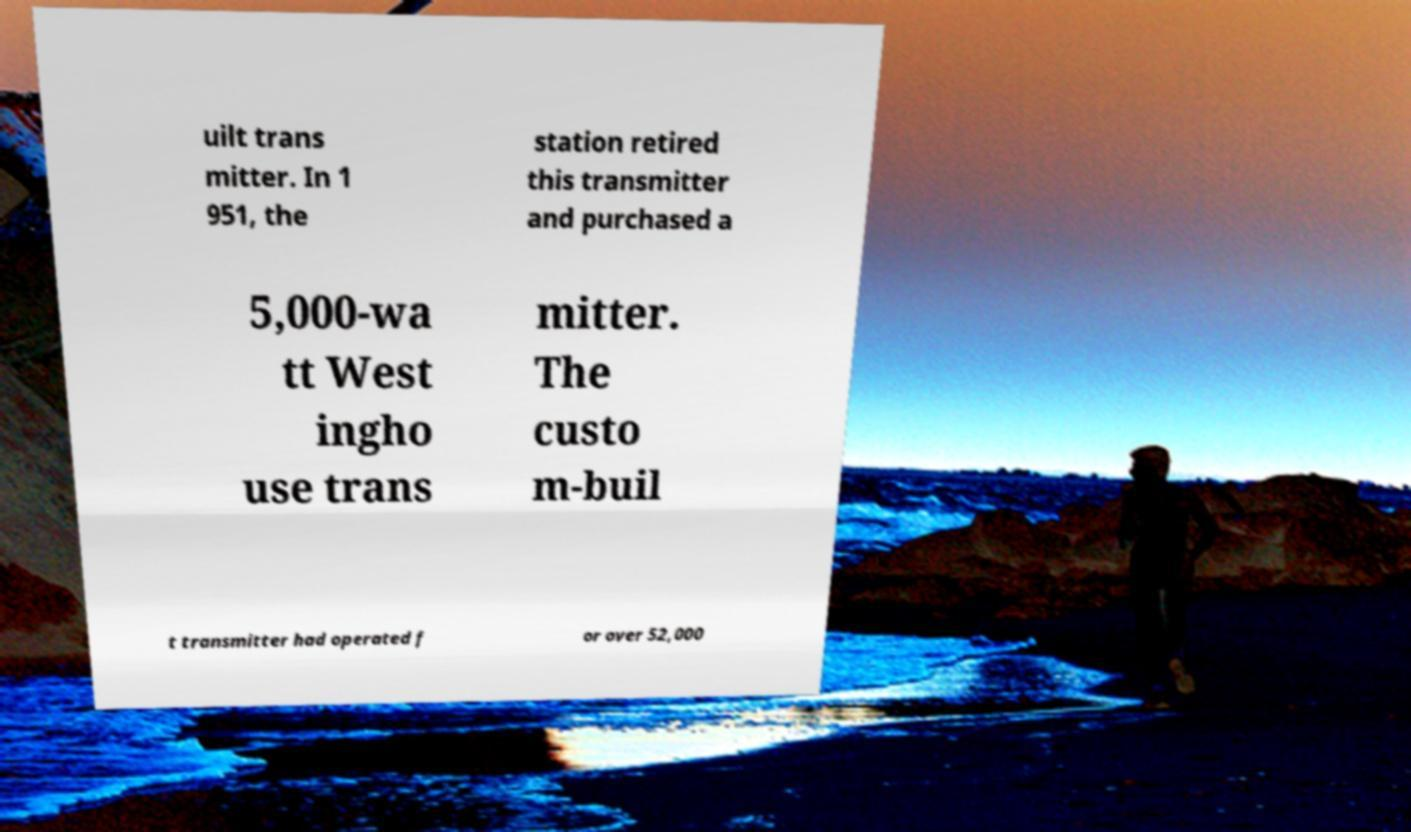What messages or text are displayed in this image? I need them in a readable, typed format. uilt trans mitter. In 1 951, the station retired this transmitter and purchased a 5,000-wa tt West ingho use trans mitter. The custo m-buil t transmitter had operated f or over 52,000 